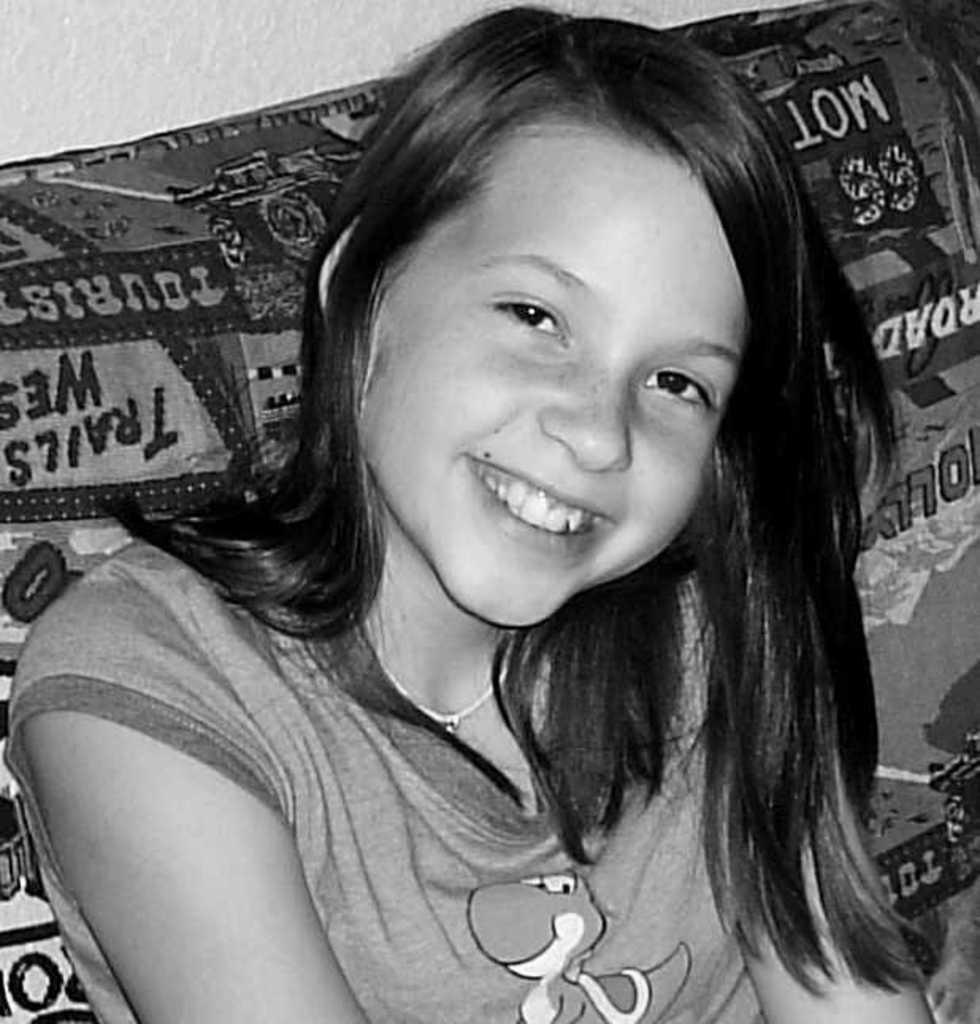Can you describe this image briefly? This is a black and white image. It looks like a couch and a girl is sitting on it. At the top of the image, it looks like a wall. 